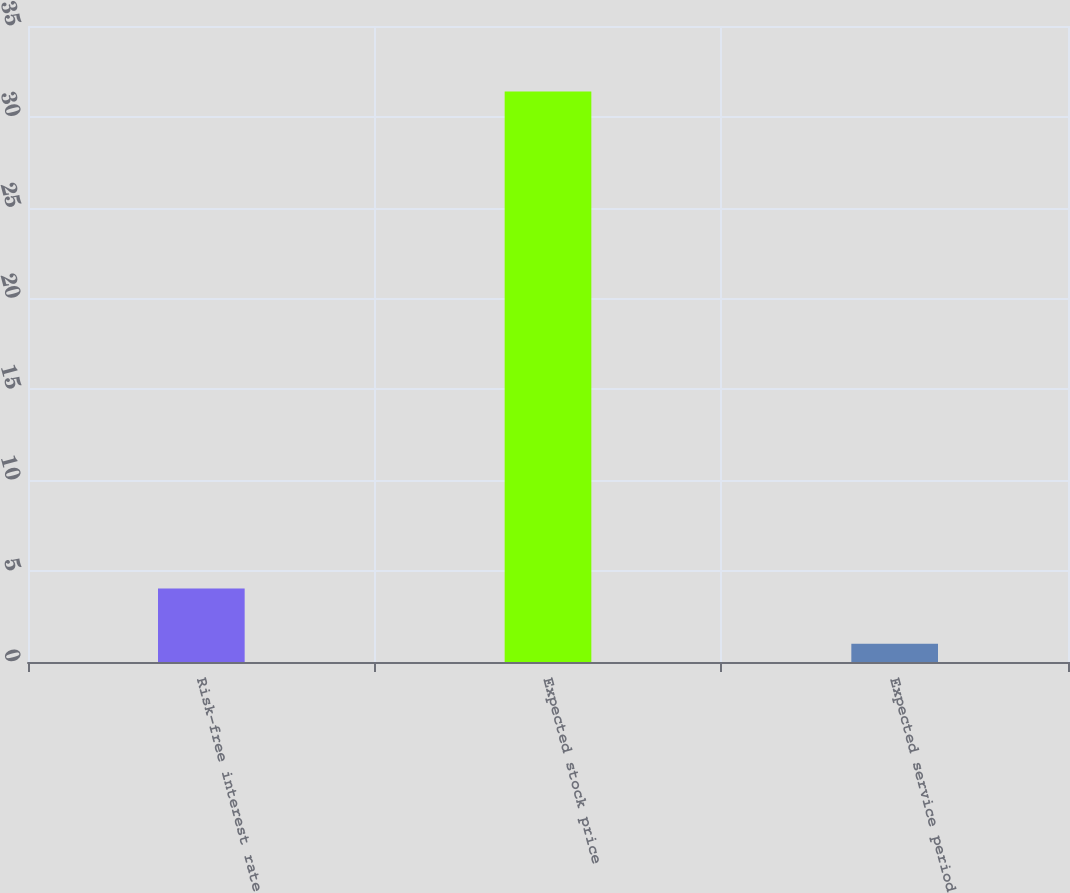Convert chart to OTSL. <chart><loc_0><loc_0><loc_500><loc_500><bar_chart><fcel>Risk-free interest rate<fcel>Expected stock price<fcel>Expected service period<nl><fcel>4.04<fcel>31.4<fcel>1<nl></chart> 